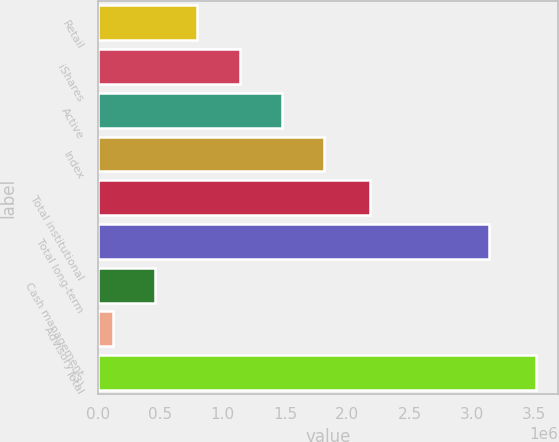Convert chart. <chart><loc_0><loc_0><loc_500><loc_500><bar_chart><fcel>Retail<fcel>iShares<fcel>Active<fcel>Index<fcel>Total institutional<fcel>Total long-term<fcel>Cash management<fcel>Advisory (3)<fcel>Total<nl><fcel>798592<fcel>1.13785e+06<fcel>1.47711e+06<fcel>1.81638e+06<fcel>2.18123e+06<fcel>3.13795e+06<fcel>459331<fcel>120070<fcel>3.51268e+06<nl></chart> 